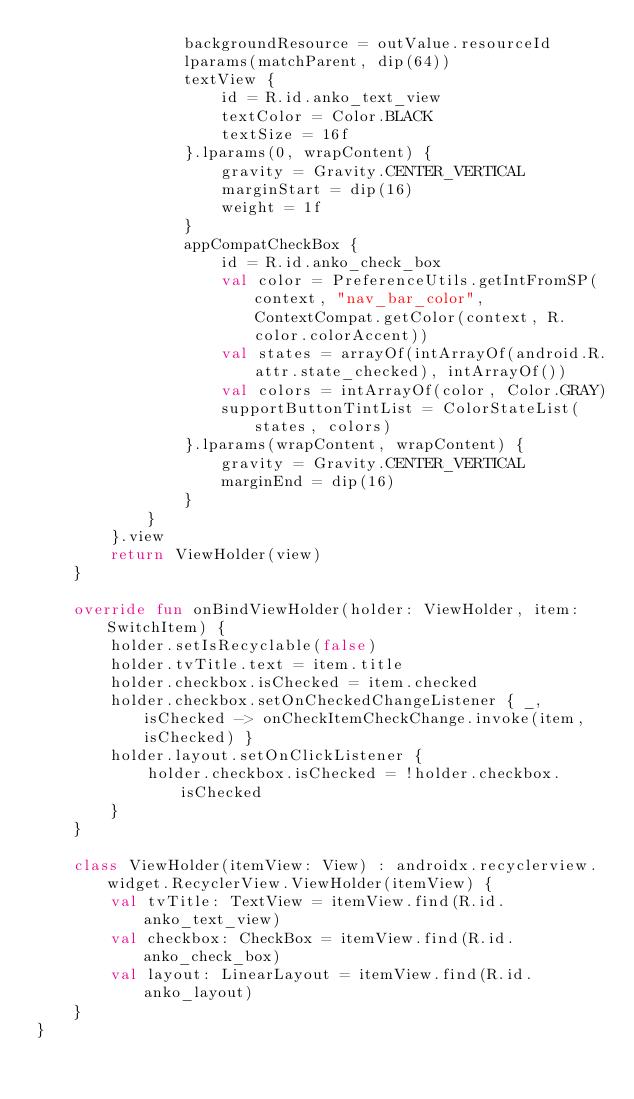<code> <loc_0><loc_0><loc_500><loc_500><_Kotlin_>                backgroundResource = outValue.resourceId
                lparams(matchParent, dip(64))
                textView {
                    id = R.id.anko_text_view
                    textColor = Color.BLACK
                    textSize = 16f
                }.lparams(0, wrapContent) {
                    gravity = Gravity.CENTER_VERTICAL
                    marginStart = dip(16)
                    weight = 1f
                }
                appCompatCheckBox {
                    id = R.id.anko_check_box
                    val color = PreferenceUtils.getIntFromSP(context, "nav_bar_color", ContextCompat.getColor(context, R.color.colorAccent))
                    val states = arrayOf(intArrayOf(android.R.attr.state_checked), intArrayOf())
                    val colors = intArrayOf(color, Color.GRAY)
                    supportButtonTintList = ColorStateList(states, colors)
                }.lparams(wrapContent, wrapContent) {
                    gravity = Gravity.CENTER_VERTICAL
                    marginEnd = dip(16)
                }
            }
        }.view
        return ViewHolder(view)
    }

    override fun onBindViewHolder(holder: ViewHolder, item: SwitchItem) {
        holder.setIsRecyclable(false)
        holder.tvTitle.text = item.title
        holder.checkbox.isChecked = item.checked
        holder.checkbox.setOnCheckedChangeListener { _, isChecked -> onCheckItemCheckChange.invoke(item, isChecked) }
        holder.layout.setOnClickListener {
            holder.checkbox.isChecked = !holder.checkbox.isChecked
        }
    }

    class ViewHolder(itemView: View) : androidx.recyclerview.widget.RecyclerView.ViewHolder(itemView) {
        val tvTitle: TextView = itemView.find(R.id.anko_text_view)
        val checkbox: CheckBox = itemView.find(R.id.anko_check_box)
        val layout: LinearLayout = itemView.find(R.id.anko_layout)
    }
}</code> 